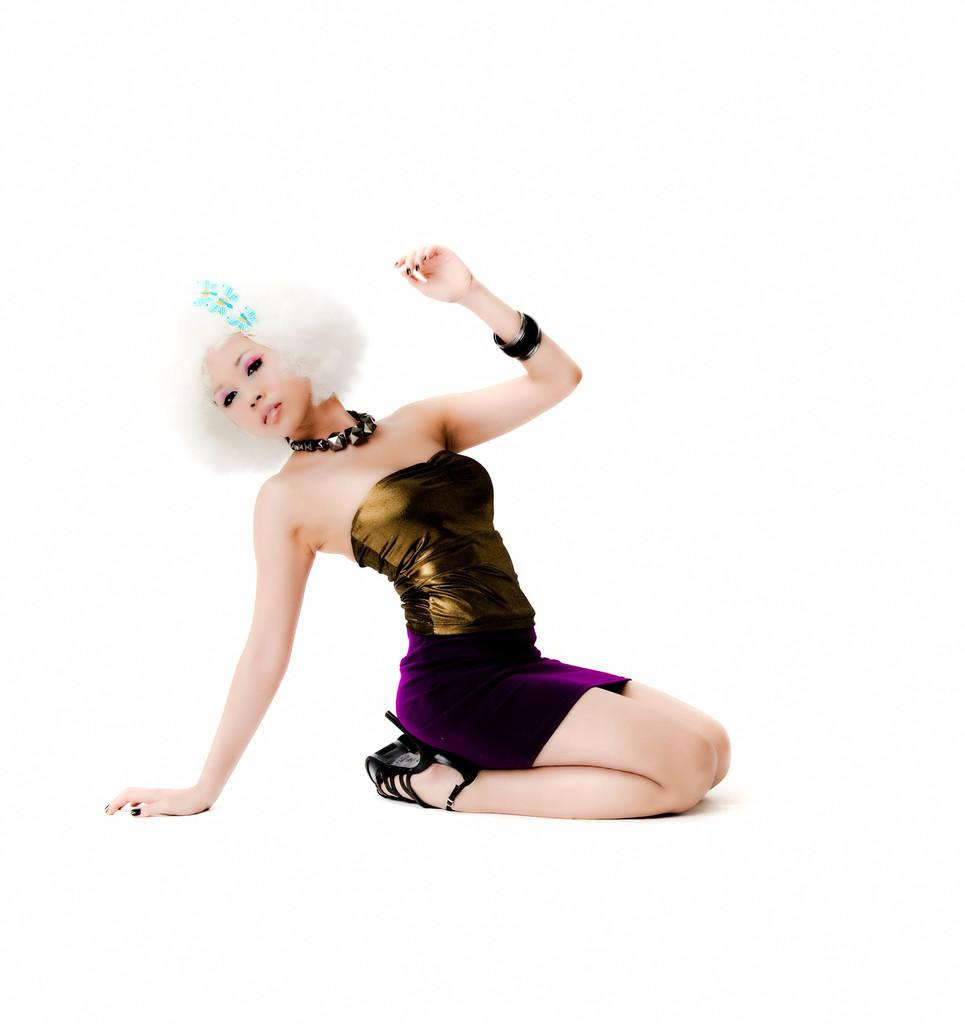What is the color of the background in the image? The background of the picture is white. Can you describe the person in the image? There is a woman in the image. What accessories is the woman wearing? The woman is wearing a bracelet and a necklace. What is the woman doing in the image? The woman is giving a pose. How is the woman described in the image? The woman is described as beautiful. What type of plastic material can be seen melting in the image? There is no plastic material or melting process visible in the image. 